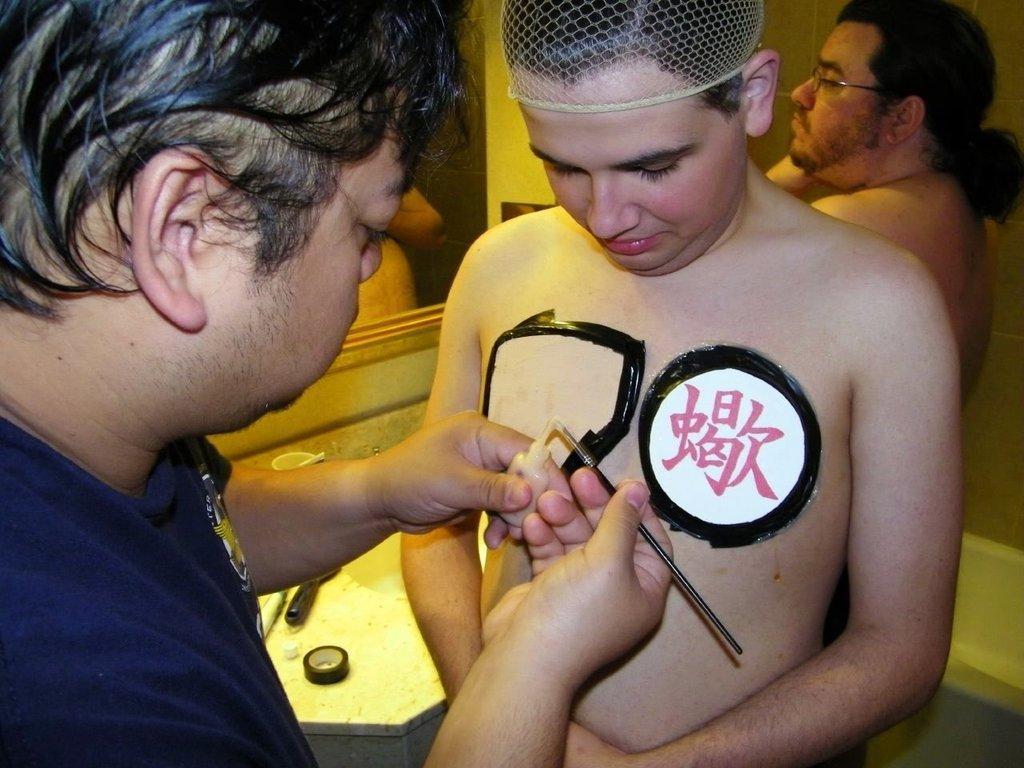How would you summarize this image in a sentence or two? In this image I can see three persons on the left side person he holding a small bottle , in the middle I can see a mirror and a table. 